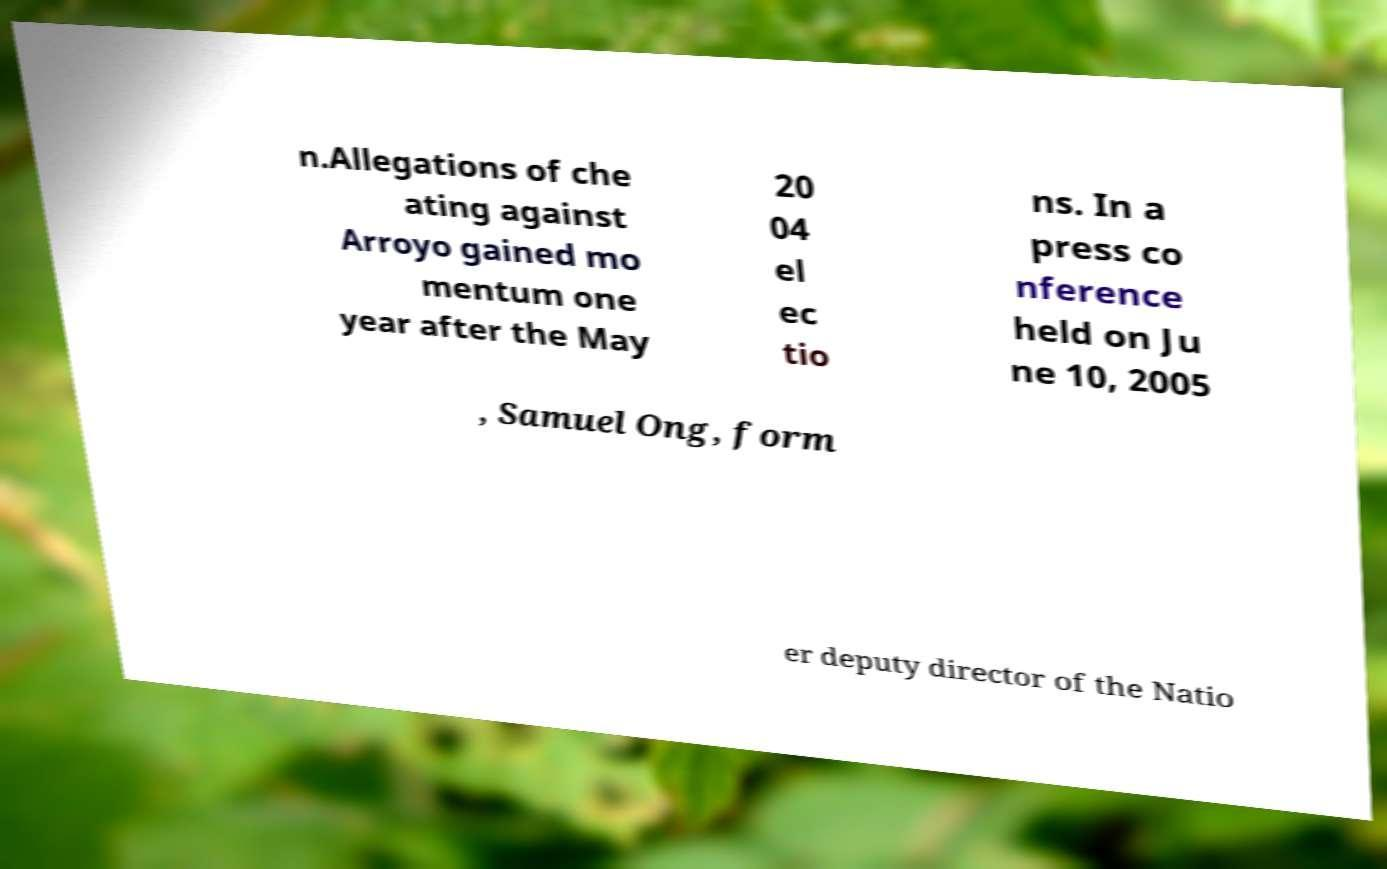Can you read and provide the text displayed in the image?This photo seems to have some interesting text. Can you extract and type it out for me? n.Allegations of che ating against Arroyo gained mo mentum one year after the May 20 04 el ec tio ns. In a press co nference held on Ju ne 10, 2005 , Samuel Ong, form er deputy director of the Natio 